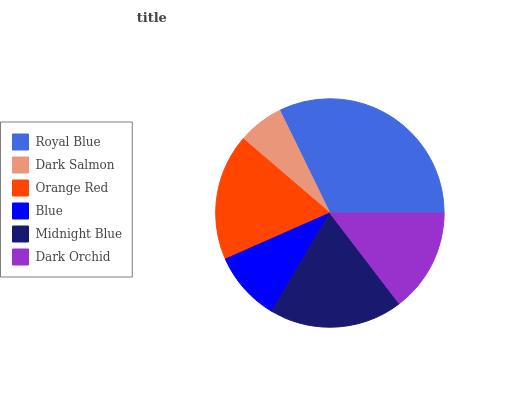Is Dark Salmon the minimum?
Answer yes or no. Yes. Is Royal Blue the maximum?
Answer yes or no. Yes. Is Orange Red the minimum?
Answer yes or no. No. Is Orange Red the maximum?
Answer yes or no. No. Is Orange Red greater than Dark Salmon?
Answer yes or no. Yes. Is Dark Salmon less than Orange Red?
Answer yes or no. Yes. Is Dark Salmon greater than Orange Red?
Answer yes or no. No. Is Orange Red less than Dark Salmon?
Answer yes or no. No. Is Orange Red the high median?
Answer yes or no. Yes. Is Dark Orchid the low median?
Answer yes or no. Yes. Is Royal Blue the high median?
Answer yes or no. No. Is Blue the low median?
Answer yes or no. No. 